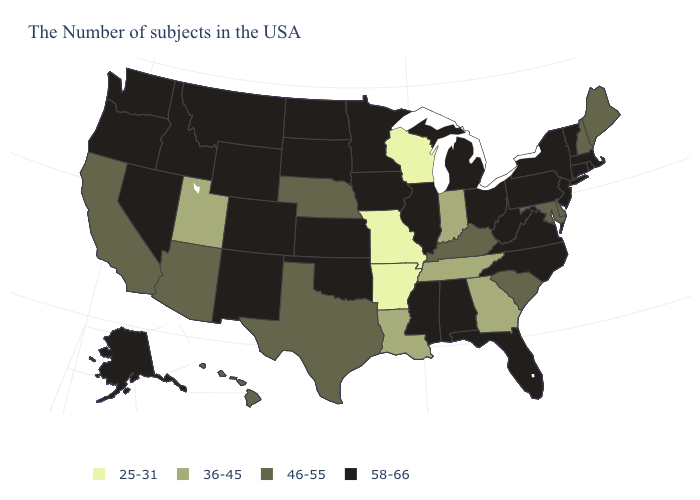What is the highest value in states that border North Carolina?
Concise answer only. 58-66. Does the map have missing data?
Answer briefly. No. What is the value of Tennessee?
Concise answer only. 36-45. Does the map have missing data?
Quick response, please. No. Does the first symbol in the legend represent the smallest category?
Concise answer only. Yes. Name the states that have a value in the range 46-55?
Quick response, please. Maine, New Hampshire, Delaware, Maryland, South Carolina, Kentucky, Nebraska, Texas, Arizona, California, Hawaii. Among the states that border Illinois , which have the highest value?
Quick response, please. Iowa. Among the states that border Montana , which have the lowest value?
Keep it brief. South Dakota, North Dakota, Wyoming, Idaho. How many symbols are there in the legend?
Be succinct. 4. What is the value of Connecticut?
Concise answer only. 58-66. What is the highest value in the MidWest ?
Quick response, please. 58-66. Which states hav the highest value in the West?
Keep it brief. Wyoming, Colorado, New Mexico, Montana, Idaho, Nevada, Washington, Oregon, Alaska. Does Delaware have a higher value than South Dakota?
Answer briefly. No. What is the highest value in the USA?
Give a very brief answer. 58-66. What is the value of New Jersey?
Write a very short answer. 58-66. 